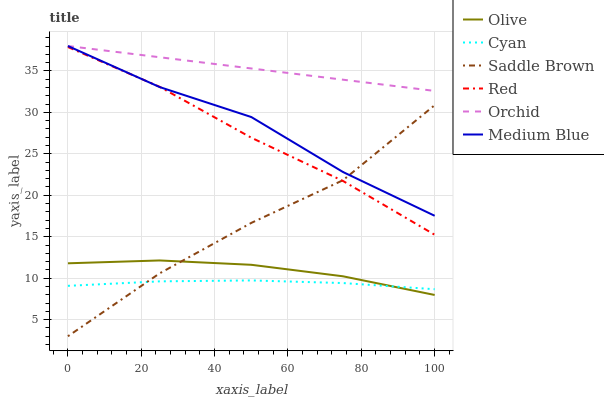Does Cyan have the minimum area under the curve?
Answer yes or no. Yes. Does Orchid have the maximum area under the curve?
Answer yes or no. Yes. Does Olive have the minimum area under the curve?
Answer yes or no. No. Does Olive have the maximum area under the curve?
Answer yes or no. No. Is Orchid the smoothest?
Answer yes or no. Yes. Is Saddle Brown the roughest?
Answer yes or no. Yes. Is Olive the smoothest?
Answer yes or no. No. Is Olive the roughest?
Answer yes or no. No. Does Olive have the lowest value?
Answer yes or no. No. Does Orchid have the highest value?
Answer yes or no. Yes. Does Olive have the highest value?
Answer yes or no. No. Is Saddle Brown less than Orchid?
Answer yes or no. Yes. Is Orchid greater than Saddle Brown?
Answer yes or no. Yes. Does Red intersect Saddle Brown?
Answer yes or no. Yes. Is Red less than Saddle Brown?
Answer yes or no. No. Is Red greater than Saddle Brown?
Answer yes or no. No. Does Saddle Brown intersect Orchid?
Answer yes or no. No. 